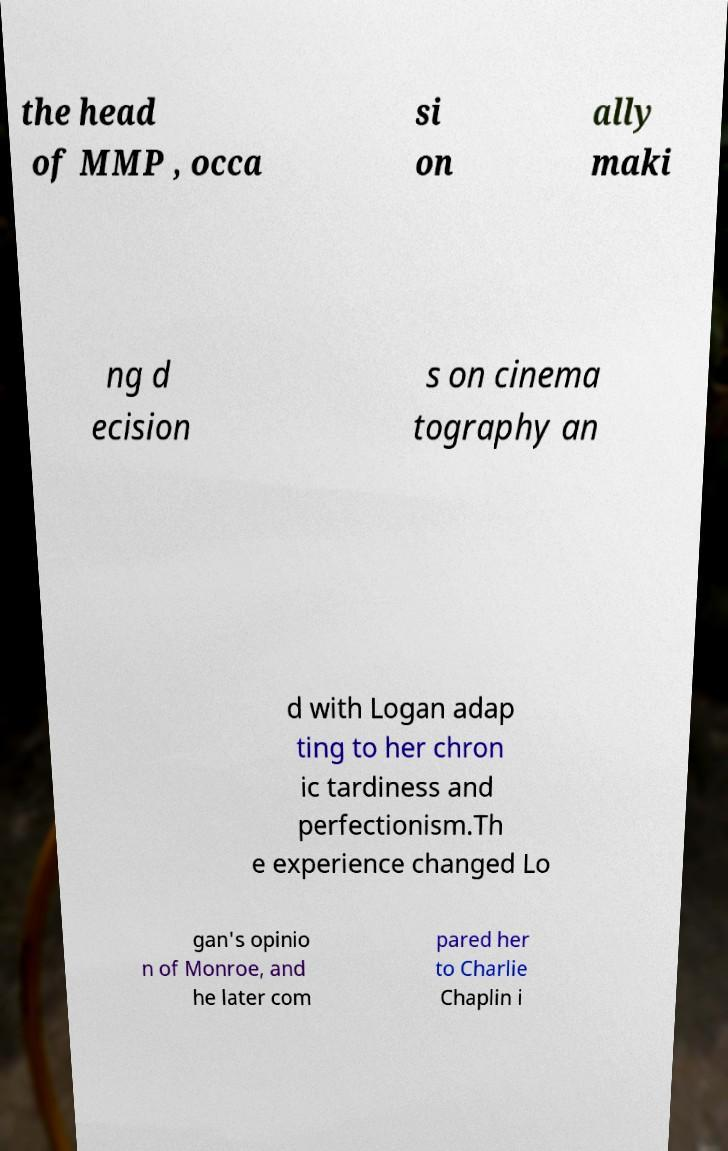Can you read and provide the text displayed in the image?This photo seems to have some interesting text. Can you extract and type it out for me? the head of MMP , occa si on ally maki ng d ecision s on cinema tography an d with Logan adap ting to her chron ic tardiness and perfectionism.Th e experience changed Lo gan's opinio n of Monroe, and he later com pared her to Charlie Chaplin i 